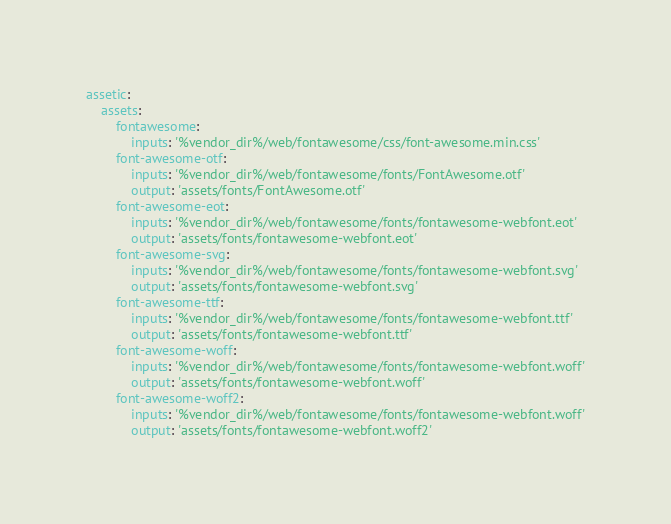Convert code to text. <code><loc_0><loc_0><loc_500><loc_500><_YAML_>assetic:
    assets:
        fontawesome:
            inputs: '%vendor_dir%/web/fontawesome/css/font-awesome.min.css'
        font-awesome-otf:
            inputs: '%vendor_dir%/web/fontawesome/fonts/FontAwesome.otf'
            output: 'assets/fonts/FontAwesome.otf'
        font-awesome-eot:
            inputs: '%vendor_dir%/web/fontawesome/fonts/fontawesome-webfont.eot'
            output: 'assets/fonts/fontawesome-webfont.eot'
        font-awesome-svg:
            inputs: '%vendor_dir%/web/fontawesome/fonts/fontawesome-webfont.svg'
            output: 'assets/fonts/fontawesome-webfont.svg'
        font-awesome-ttf:
            inputs: '%vendor_dir%/web/fontawesome/fonts/fontawesome-webfont.ttf'
            output: 'assets/fonts/fontawesome-webfont.ttf'
        font-awesome-woff:
            inputs: '%vendor_dir%/web/fontawesome/fonts/fontawesome-webfont.woff'
            output: 'assets/fonts/fontawesome-webfont.woff'
        font-awesome-woff2:
            inputs: '%vendor_dir%/web/fontawesome/fonts/fontawesome-webfont.woff'
            output: 'assets/fonts/fontawesome-webfont.woff2'
</code> 